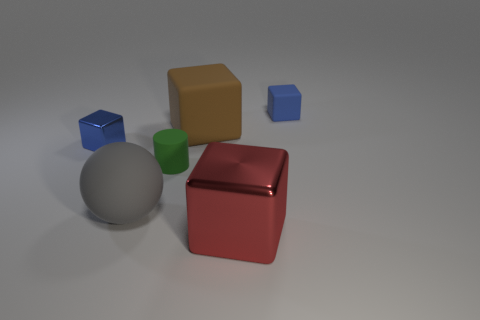There is a rubber cylinder; is it the same size as the blue thing that is behind the blue metallic object?
Your answer should be compact. Yes. There is a small blue block that is in front of the brown matte block; what is its material?
Offer a terse response. Metal. Is the number of rubber blocks left of the brown thing the same as the number of red cubes?
Your response must be concise. No. Do the red thing and the brown block have the same size?
Offer a terse response. Yes. Is there a tiny blue shiny cube to the right of the big block in front of the metal block to the left of the tiny green rubber thing?
Keep it short and to the point. No. What is the material of the red object that is the same shape as the brown thing?
Provide a succinct answer. Metal. How many balls are behind the big cube behind the gray rubber ball?
Provide a short and direct response. 0. There is a metal cube that is in front of the tiny blue cube that is to the left of the blue cube that is behind the big brown object; what size is it?
Your response must be concise. Large. What is the color of the small cube that is left of the small rubber thing that is right of the tiny green thing?
Your response must be concise. Blue. How many other objects are the same material as the green cylinder?
Your response must be concise. 3. 